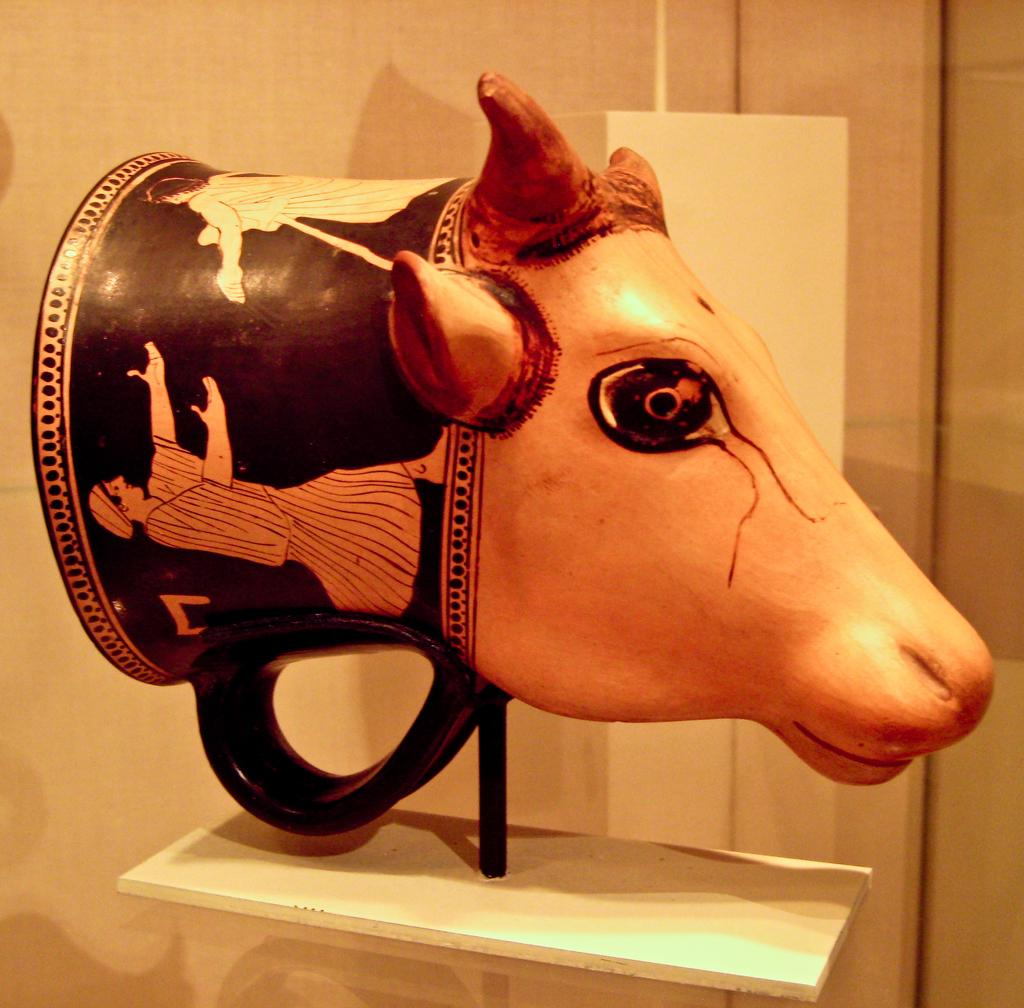What is the main subject of the image? The main subject of the image is an inflatable bull head. Where is the bull head located? The bull head is placed in a museum. What can be seen in the background of the image? There is a wall in the background of the image. What type of curtain is hanging in front of the bull head in the image? There is no curtain present in the image; the bull head is visible and not obstructed by any objects. 